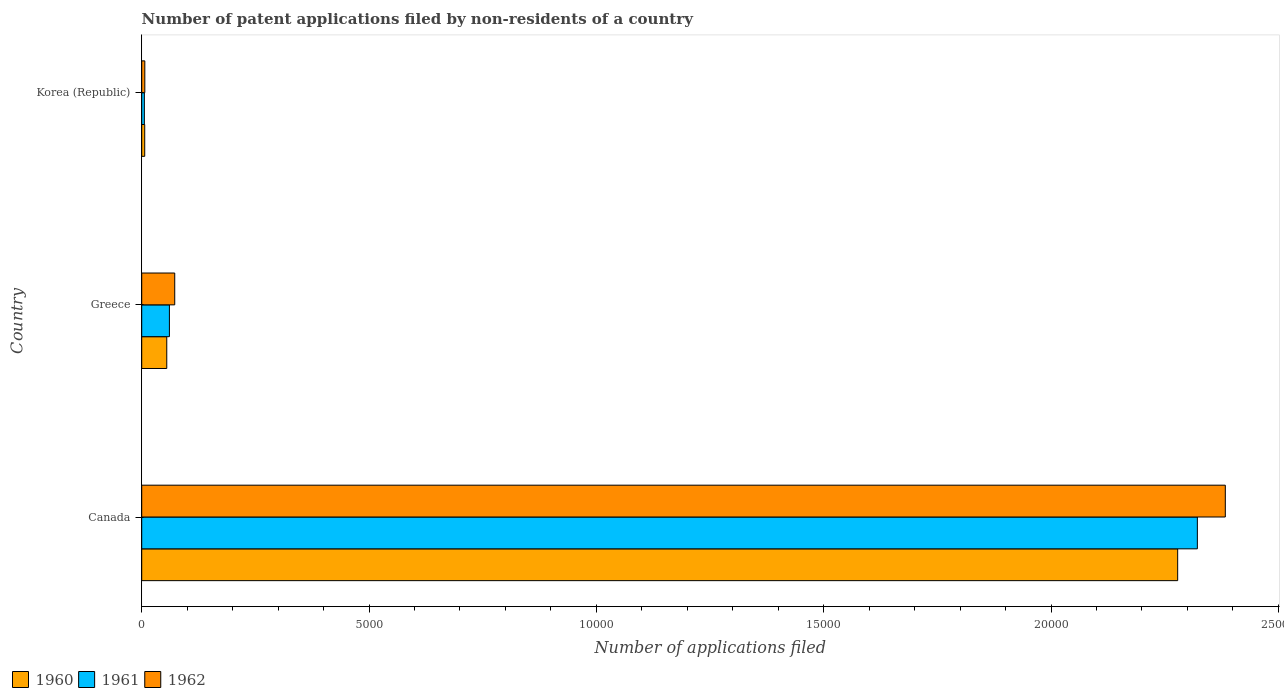How many different coloured bars are there?
Offer a terse response. 3. How many groups of bars are there?
Give a very brief answer. 3. How many bars are there on the 3rd tick from the bottom?
Ensure brevity in your answer.  3. In how many cases, is the number of bars for a given country not equal to the number of legend labels?
Offer a terse response. 0. Across all countries, what is the maximum number of applications filed in 1960?
Make the answer very short. 2.28e+04. Across all countries, what is the minimum number of applications filed in 1962?
Your answer should be very brief. 68. In which country was the number of applications filed in 1962 minimum?
Provide a short and direct response. Korea (Republic). What is the total number of applications filed in 1962 in the graph?
Provide a short and direct response. 2.46e+04. What is the difference between the number of applications filed in 1961 in Canada and that in Korea (Republic)?
Offer a terse response. 2.32e+04. What is the difference between the number of applications filed in 1961 in Greece and the number of applications filed in 1960 in Korea (Republic)?
Make the answer very short. 543. What is the average number of applications filed in 1960 per country?
Your answer should be compact. 7801. What is the ratio of the number of applications filed in 1962 in Canada to that in Korea (Republic)?
Make the answer very short. 350.5. What is the difference between the highest and the second highest number of applications filed in 1961?
Your answer should be compact. 2.26e+04. What is the difference between the highest and the lowest number of applications filed in 1962?
Offer a very short reply. 2.38e+04. In how many countries, is the number of applications filed in 1961 greater than the average number of applications filed in 1961 taken over all countries?
Give a very brief answer. 1. What does the 1st bar from the top in Greece represents?
Offer a very short reply. 1962. How many countries are there in the graph?
Provide a succinct answer. 3. What is the difference between two consecutive major ticks on the X-axis?
Your response must be concise. 5000. What is the title of the graph?
Offer a very short reply. Number of patent applications filed by non-residents of a country. What is the label or title of the X-axis?
Provide a succinct answer. Number of applications filed. What is the Number of applications filed of 1960 in Canada?
Keep it short and to the point. 2.28e+04. What is the Number of applications filed of 1961 in Canada?
Ensure brevity in your answer.  2.32e+04. What is the Number of applications filed of 1962 in Canada?
Your answer should be compact. 2.38e+04. What is the Number of applications filed of 1960 in Greece?
Keep it short and to the point. 551. What is the Number of applications filed of 1961 in Greece?
Your answer should be very brief. 609. What is the Number of applications filed of 1962 in Greece?
Offer a terse response. 726. What is the Number of applications filed of 1960 in Korea (Republic)?
Your response must be concise. 66. What is the Number of applications filed in 1961 in Korea (Republic)?
Give a very brief answer. 58. Across all countries, what is the maximum Number of applications filed of 1960?
Offer a terse response. 2.28e+04. Across all countries, what is the maximum Number of applications filed of 1961?
Offer a very short reply. 2.32e+04. Across all countries, what is the maximum Number of applications filed of 1962?
Your answer should be very brief. 2.38e+04. Across all countries, what is the minimum Number of applications filed in 1960?
Offer a terse response. 66. Across all countries, what is the minimum Number of applications filed of 1961?
Your answer should be compact. 58. Across all countries, what is the minimum Number of applications filed in 1962?
Your answer should be very brief. 68. What is the total Number of applications filed in 1960 in the graph?
Provide a short and direct response. 2.34e+04. What is the total Number of applications filed of 1961 in the graph?
Your response must be concise. 2.39e+04. What is the total Number of applications filed in 1962 in the graph?
Make the answer very short. 2.46e+04. What is the difference between the Number of applications filed of 1960 in Canada and that in Greece?
Give a very brief answer. 2.22e+04. What is the difference between the Number of applications filed in 1961 in Canada and that in Greece?
Your answer should be compact. 2.26e+04. What is the difference between the Number of applications filed in 1962 in Canada and that in Greece?
Provide a short and direct response. 2.31e+04. What is the difference between the Number of applications filed of 1960 in Canada and that in Korea (Republic)?
Provide a succinct answer. 2.27e+04. What is the difference between the Number of applications filed of 1961 in Canada and that in Korea (Republic)?
Offer a very short reply. 2.32e+04. What is the difference between the Number of applications filed in 1962 in Canada and that in Korea (Republic)?
Provide a short and direct response. 2.38e+04. What is the difference between the Number of applications filed of 1960 in Greece and that in Korea (Republic)?
Ensure brevity in your answer.  485. What is the difference between the Number of applications filed of 1961 in Greece and that in Korea (Republic)?
Ensure brevity in your answer.  551. What is the difference between the Number of applications filed in 1962 in Greece and that in Korea (Republic)?
Ensure brevity in your answer.  658. What is the difference between the Number of applications filed of 1960 in Canada and the Number of applications filed of 1961 in Greece?
Make the answer very short. 2.22e+04. What is the difference between the Number of applications filed of 1960 in Canada and the Number of applications filed of 1962 in Greece?
Provide a succinct answer. 2.21e+04. What is the difference between the Number of applications filed of 1961 in Canada and the Number of applications filed of 1962 in Greece?
Offer a very short reply. 2.25e+04. What is the difference between the Number of applications filed in 1960 in Canada and the Number of applications filed in 1961 in Korea (Republic)?
Offer a terse response. 2.27e+04. What is the difference between the Number of applications filed in 1960 in Canada and the Number of applications filed in 1962 in Korea (Republic)?
Offer a terse response. 2.27e+04. What is the difference between the Number of applications filed of 1961 in Canada and the Number of applications filed of 1962 in Korea (Republic)?
Provide a short and direct response. 2.32e+04. What is the difference between the Number of applications filed in 1960 in Greece and the Number of applications filed in 1961 in Korea (Republic)?
Ensure brevity in your answer.  493. What is the difference between the Number of applications filed in 1960 in Greece and the Number of applications filed in 1962 in Korea (Republic)?
Keep it short and to the point. 483. What is the difference between the Number of applications filed in 1961 in Greece and the Number of applications filed in 1962 in Korea (Republic)?
Make the answer very short. 541. What is the average Number of applications filed of 1960 per country?
Give a very brief answer. 7801. What is the average Number of applications filed of 1961 per country?
Provide a succinct answer. 7962. What is the average Number of applications filed of 1962 per country?
Offer a terse response. 8209.33. What is the difference between the Number of applications filed of 1960 and Number of applications filed of 1961 in Canada?
Give a very brief answer. -433. What is the difference between the Number of applications filed of 1960 and Number of applications filed of 1962 in Canada?
Your response must be concise. -1048. What is the difference between the Number of applications filed in 1961 and Number of applications filed in 1962 in Canada?
Provide a succinct answer. -615. What is the difference between the Number of applications filed in 1960 and Number of applications filed in 1961 in Greece?
Your response must be concise. -58. What is the difference between the Number of applications filed in 1960 and Number of applications filed in 1962 in Greece?
Offer a terse response. -175. What is the difference between the Number of applications filed of 1961 and Number of applications filed of 1962 in Greece?
Ensure brevity in your answer.  -117. What is the difference between the Number of applications filed of 1961 and Number of applications filed of 1962 in Korea (Republic)?
Your response must be concise. -10. What is the ratio of the Number of applications filed in 1960 in Canada to that in Greece?
Ensure brevity in your answer.  41.35. What is the ratio of the Number of applications filed in 1961 in Canada to that in Greece?
Your answer should be very brief. 38.13. What is the ratio of the Number of applications filed of 1962 in Canada to that in Greece?
Make the answer very short. 32.83. What is the ratio of the Number of applications filed in 1960 in Canada to that in Korea (Republic)?
Your answer should be compact. 345.24. What is the ratio of the Number of applications filed of 1961 in Canada to that in Korea (Republic)?
Give a very brief answer. 400.33. What is the ratio of the Number of applications filed in 1962 in Canada to that in Korea (Republic)?
Your response must be concise. 350.5. What is the ratio of the Number of applications filed of 1960 in Greece to that in Korea (Republic)?
Offer a very short reply. 8.35. What is the ratio of the Number of applications filed of 1961 in Greece to that in Korea (Republic)?
Offer a terse response. 10.5. What is the ratio of the Number of applications filed of 1962 in Greece to that in Korea (Republic)?
Your response must be concise. 10.68. What is the difference between the highest and the second highest Number of applications filed in 1960?
Provide a succinct answer. 2.22e+04. What is the difference between the highest and the second highest Number of applications filed of 1961?
Offer a terse response. 2.26e+04. What is the difference between the highest and the second highest Number of applications filed of 1962?
Provide a succinct answer. 2.31e+04. What is the difference between the highest and the lowest Number of applications filed in 1960?
Give a very brief answer. 2.27e+04. What is the difference between the highest and the lowest Number of applications filed in 1961?
Your response must be concise. 2.32e+04. What is the difference between the highest and the lowest Number of applications filed in 1962?
Your answer should be compact. 2.38e+04. 